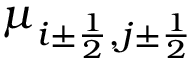Convert formula to latex. <formula><loc_0><loc_0><loc_500><loc_500>\mu _ { i \pm \frac { 1 } { 2 } , j \pm \frac { 1 } { 2 } }</formula> 